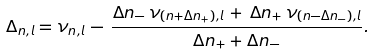<formula> <loc_0><loc_0><loc_500><loc_500>\Delta _ { n , l } = \nu _ { n , l } \, - \, \frac { \Delta n _ { - } \, \nu _ { ( n + \Delta n _ { + } ) , l } \, + \, \Delta n _ { + } \, \nu _ { ( n - \Delta n _ { - } ) , l } } { \Delta n _ { + } + \Delta n _ { - } } .</formula> 